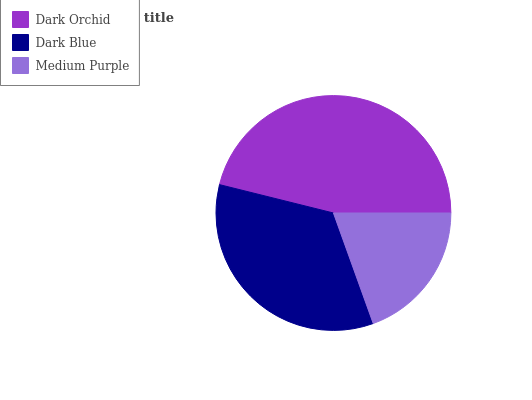Is Medium Purple the minimum?
Answer yes or no. Yes. Is Dark Orchid the maximum?
Answer yes or no. Yes. Is Dark Blue the minimum?
Answer yes or no. No. Is Dark Blue the maximum?
Answer yes or no. No. Is Dark Orchid greater than Dark Blue?
Answer yes or no. Yes. Is Dark Blue less than Dark Orchid?
Answer yes or no. Yes. Is Dark Blue greater than Dark Orchid?
Answer yes or no. No. Is Dark Orchid less than Dark Blue?
Answer yes or no. No. Is Dark Blue the high median?
Answer yes or no. Yes. Is Dark Blue the low median?
Answer yes or no. Yes. Is Medium Purple the high median?
Answer yes or no. No. Is Dark Orchid the low median?
Answer yes or no. No. 